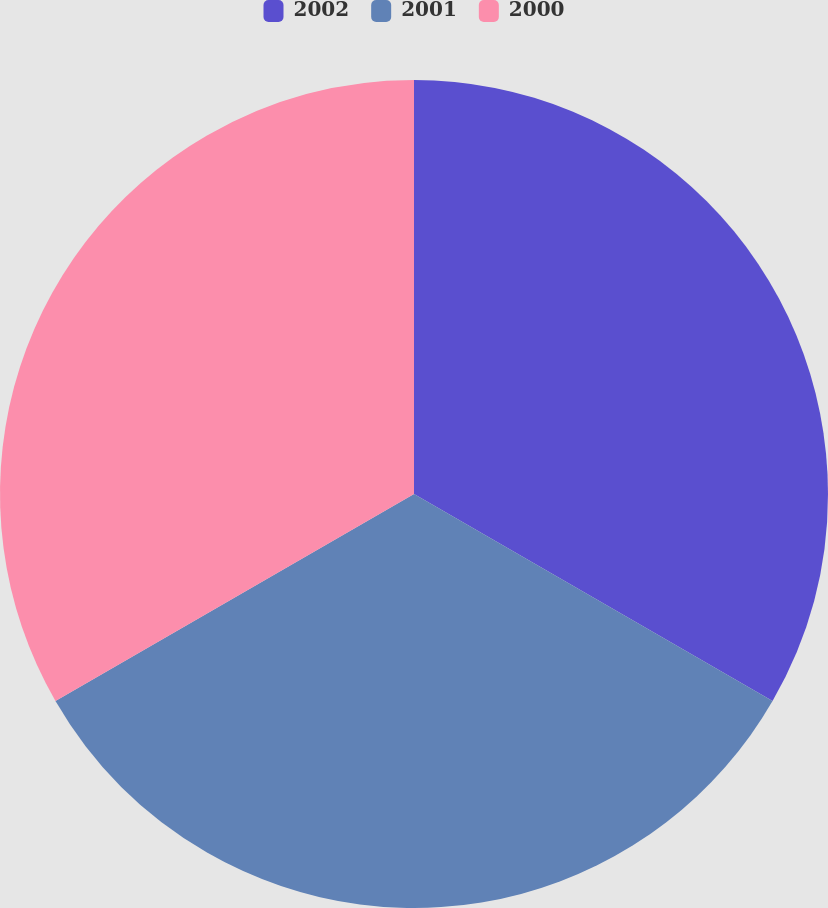Convert chart to OTSL. <chart><loc_0><loc_0><loc_500><loc_500><pie_chart><fcel>2002<fcel>2001<fcel>2000<nl><fcel>33.33%<fcel>33.33%<fcel>33.33%<nl></chart> 